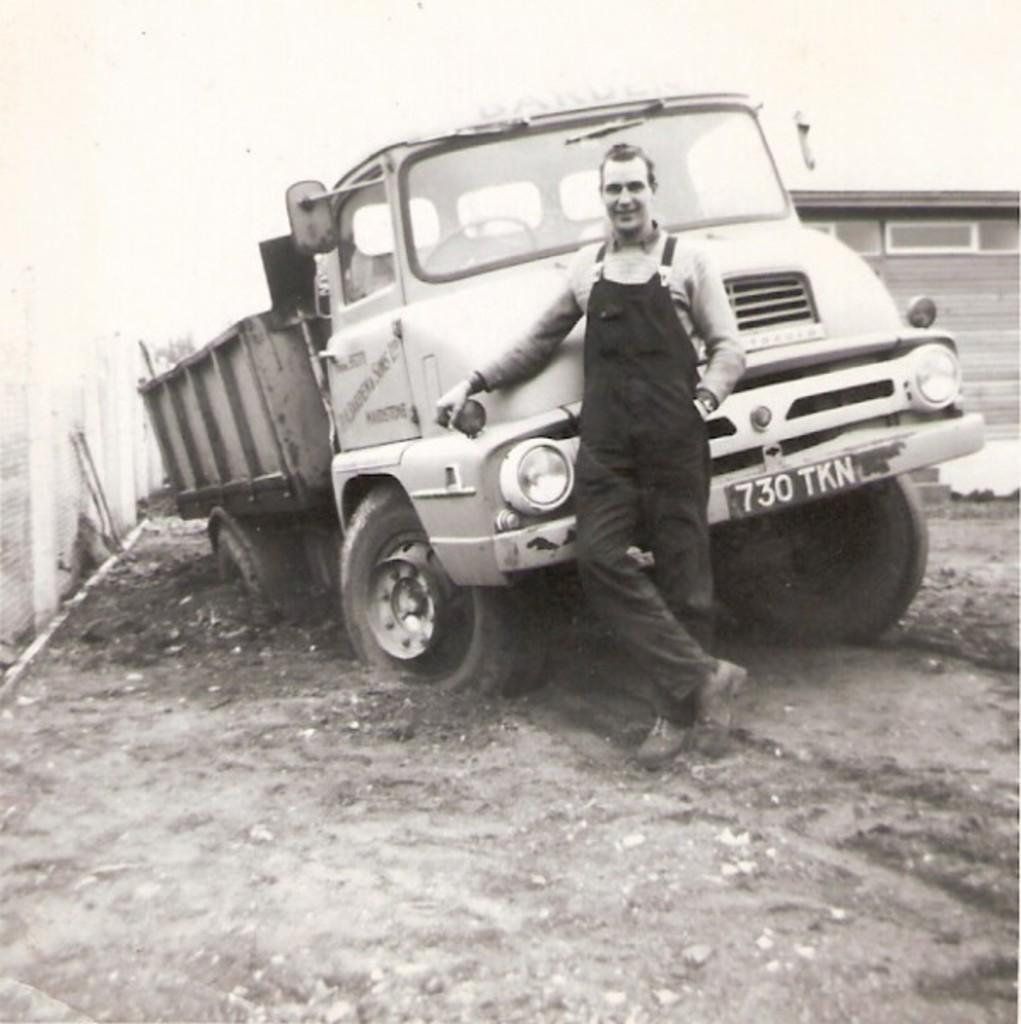What is the main subject of the image? The main subject of the image is a truck. Can you describe the man in the image? There is a man standing in front of the truck. How many crows are sitting on the truck in the image? There are no crows present in the image. What type of kitty can be seen playing with a bucket in the image? There is no kitty or bucket present in the image. 